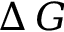<formula> <loc_0><loc_0><loc_500><loc_500>\Delta \, G</formula> 